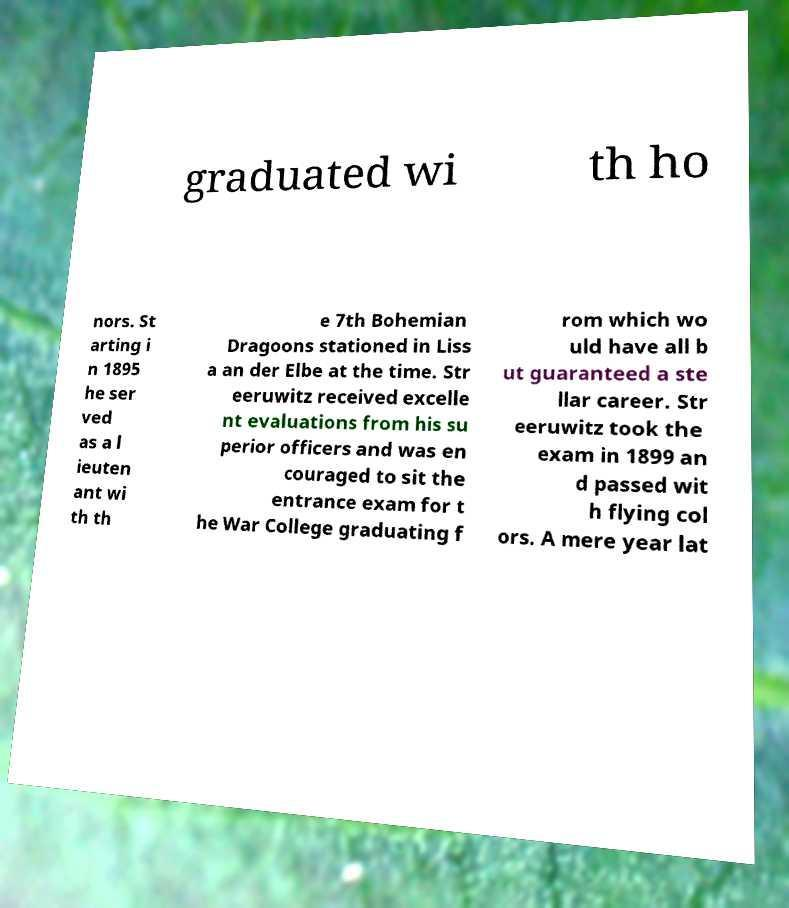There's text embedded in this image that I need extracted. Can you transcribe it verbatim? graduated wi th ho nors. St arting i n 1895 he ser ved as a l ieuten ant wi th th e 7th Bohemian Dragoons stationed in Liss a an der Elbe at the time. Str eeruwitz received excelle nt evaluations from his su perior officers and was en couraged to sit the entrance exam for t he War College graduating f rom which wo uld have all b ut guaranteed a ste llar career. Str eeruwitz took the exam in 1899 an d passed wit h flying col ors. A mere year lat 